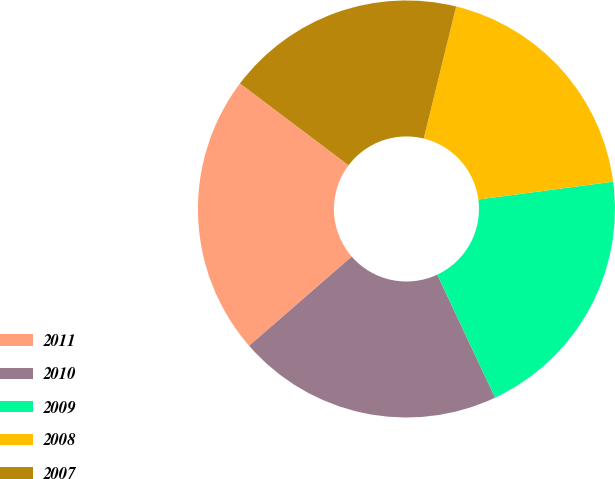<chart> <loc_0><loc_0><loc_500><loc_500><pie_chart><fcel>2011<fcel>2010<fcel>2009<fcel>2008<fcel>2007<nl><fcel>21.68%<fcel>20.6%<fcel>20.1%<fcel>19.08%<fcel>18.55%<nl></chart> 